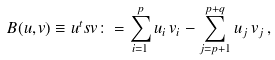Convert formula to latex. <formula><loc_0><loc_0><loc_500><loc_500>B ( u , v ) \equiv u ^ { t } s v \colon = \sum _ { i = 1 } ^ { p } u _ { i } \, v _ { i } - \sum _ { j = p + 1 } ^ { p + q } u _ { j } \, v _ { j } \, ,</formula> 